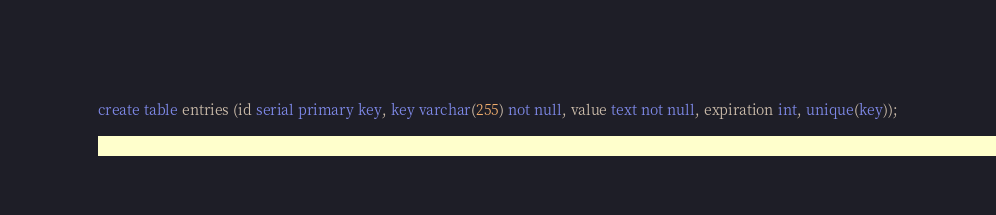Convert code to text. <code><loc_0><loc_0><loc_500><loc_500><_SQL_>create table entries (id serial primary key, key varchar(255) not null, value text not null, expiration int, unique(key));</code> 